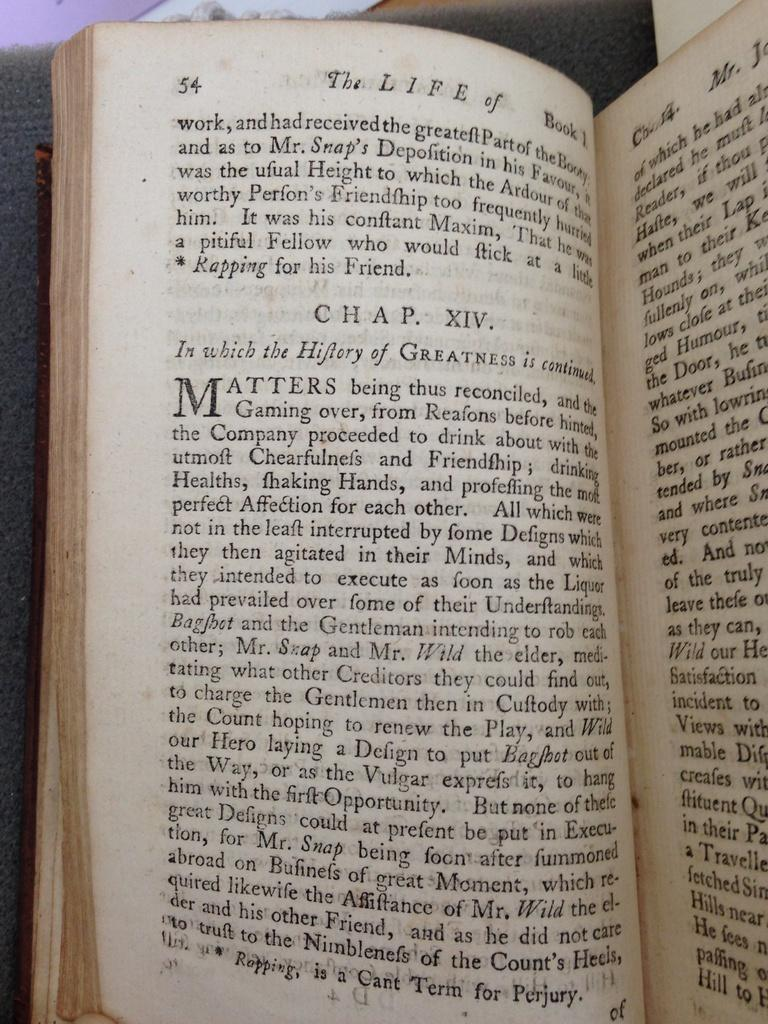Provide a one-sentence caption for the provided image. On page 54, chapter XIV starts with the words "In which". 